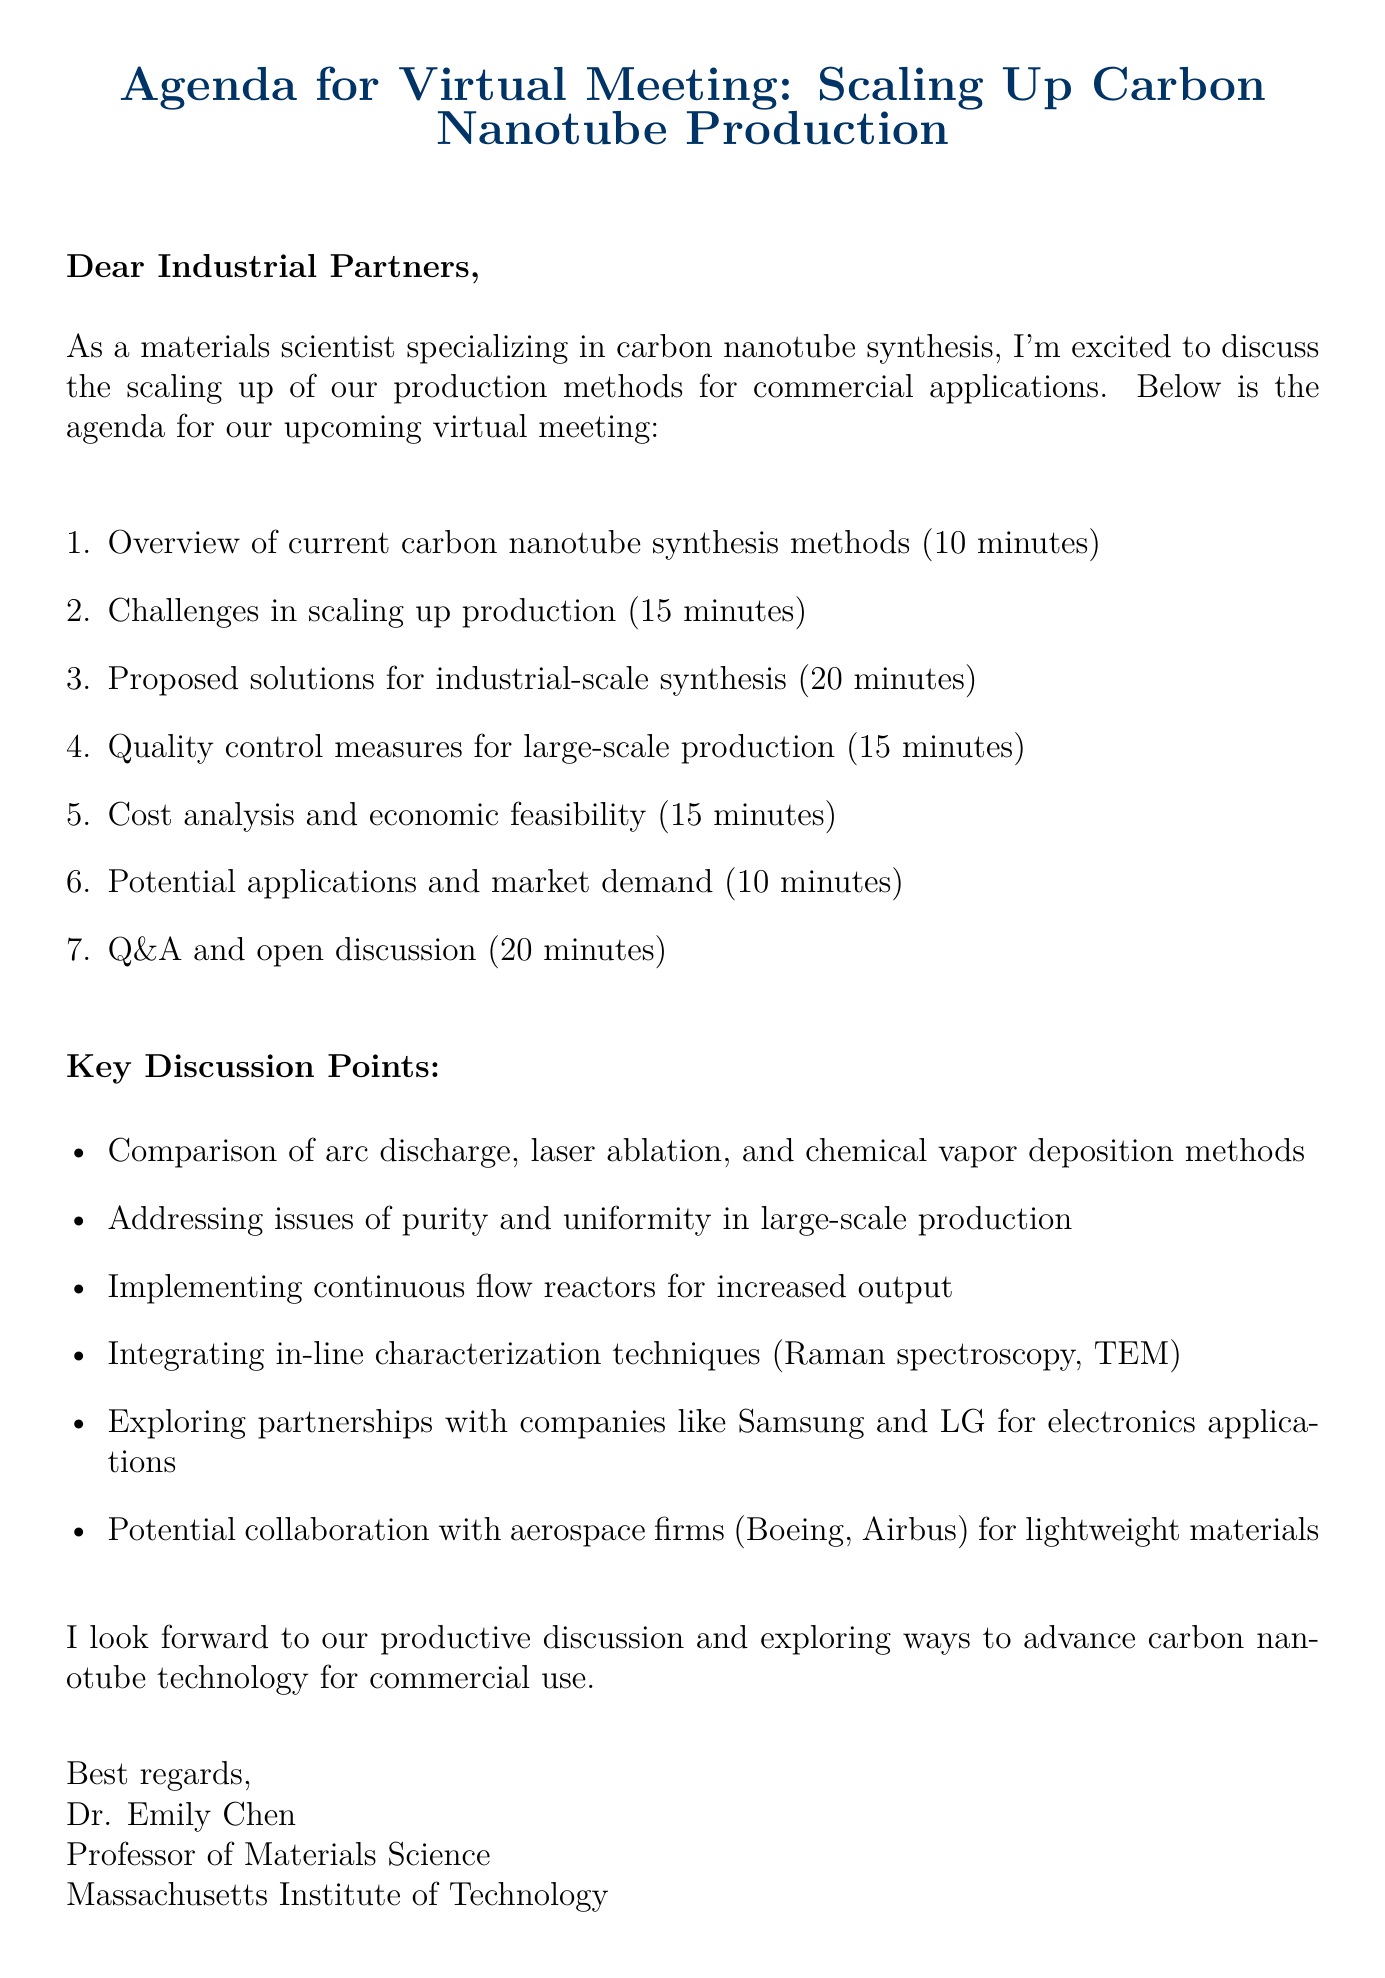What is the main subject of the email? The subject of the email is clearly stated at the beginning, which is about the upcoming meeting on scaling up production.
Answer: Agenda for Virtual Meeting: Scaling Up Carbon Nanotube Production Who is the sender of the email? The email includes a closing signature that provides the name of the sender.
Answer: Dr. Emily Chen How long is the discussion on challenges in scaling up production? The agenda specifies the duration allocated for that particular discussion point.
Answer: 15 minutes What is one proposed solution mentioned for industrial-scale synthesis? The key discussion points list various solutions suggested for scaling up production.
Answer: Implementing continuous flow reactors for increased output Which companies are suggested for potential partnerships in electronics applications? The key discussion points specifically mention companies related to electronics for potential collaboration.
Answer: Samsung and LG What duration is allotted for the Q&A and open discussion? The agenda specifies the time set aside for audience engagement at the end of the meeting.
Answer: 20 minutes What is the focus of the introduction? The introduction outlines the sender's expertise and the purpose of the meeting.
Answer: Discuss the scaling up of our production methods for commercial applications What is the closing remark indicating about the expected outcomes of the meeting? The closing remark suggests that the sender anticipates a productive dialogue regarding advancements in technology.
Answer: Exploring ways to advance carbon nanotube technology for commercial use 